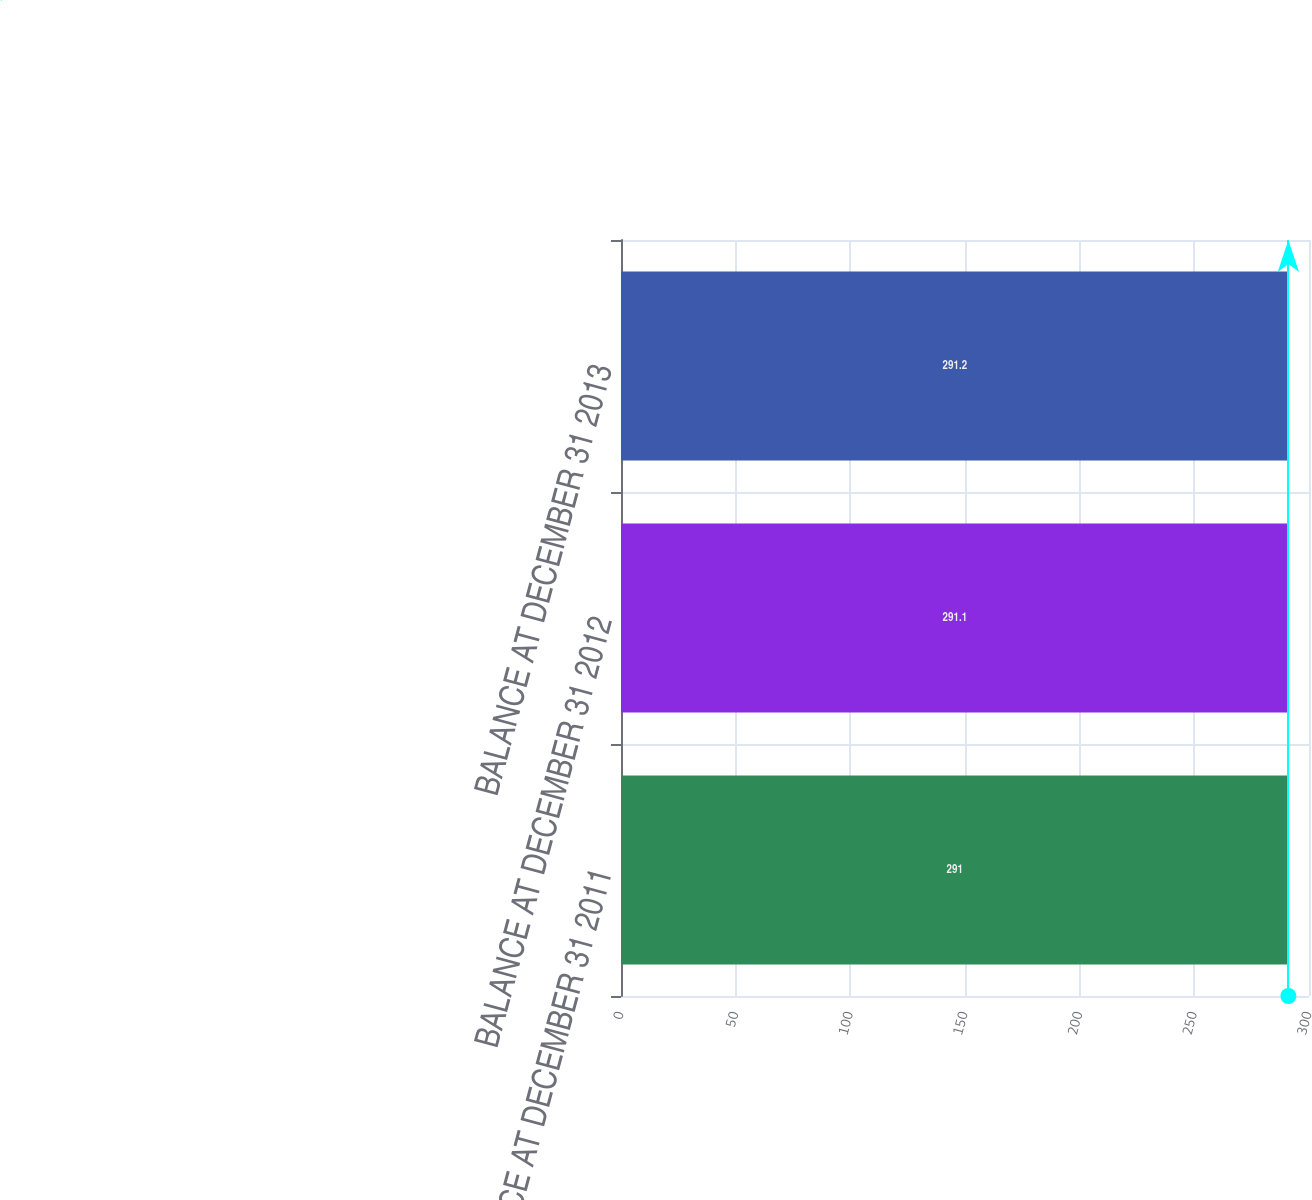Convert chart. <chart><loc_0><loc_0><loc_500><loc_500><bar_chart><fcel>BALANCE AT DECEMBER 31 2011<fcel>BALANCE AT DECEMBER 31 2012<fcel>BALANCE AT DECEMBER 31 2013<nl><fcel>291<fcel>291.1<fcel>291.2<nl></chart> 